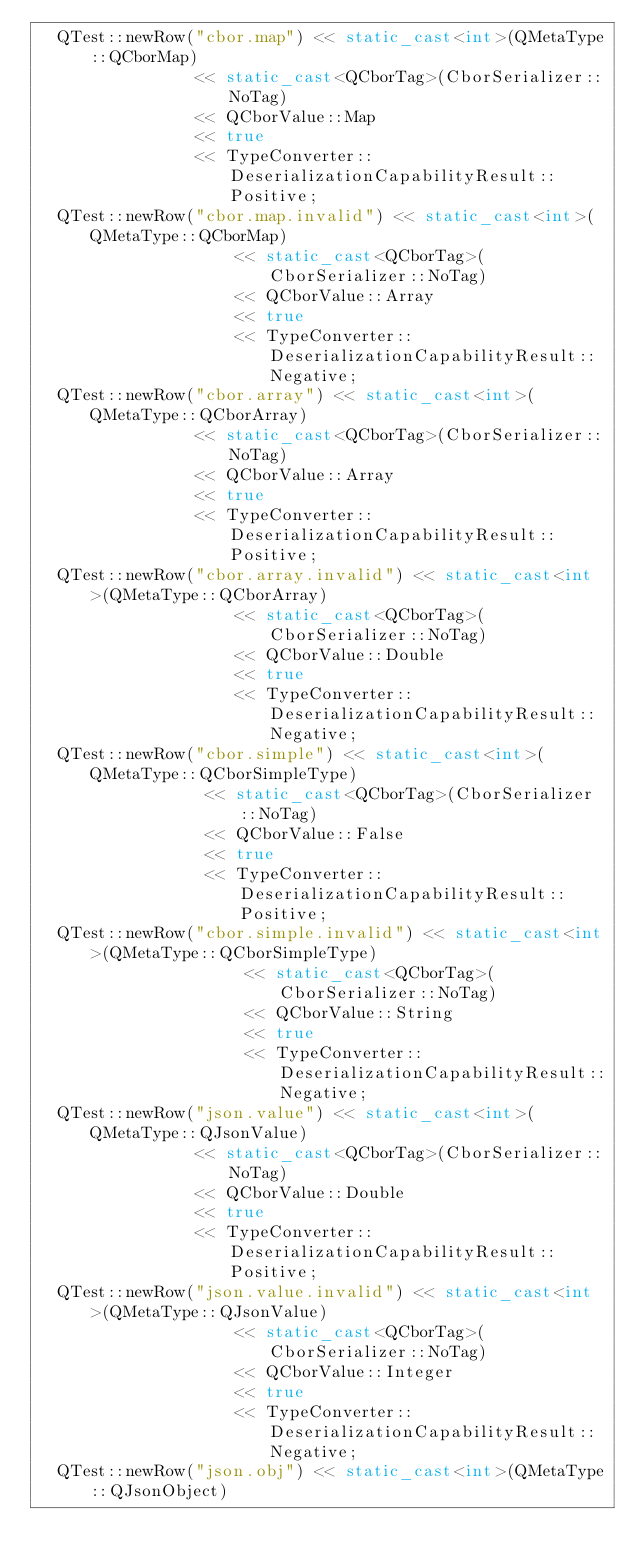<code> <loc_0><loc_0><loc_500><loc_500><_C++_>	QTest::newRow("cbor.map") << static_cast<int>(QMetaType::QCborMap)
							  << static_cast<QCborTag>(CborSerializer::NoTag)
							  << QCborValue::Map
							  << true
							  << TypeConverter::DeserializationCapabilityResult::Positive;
	QTest::newRow("cbor.map.invalid") << static_cast<int>(QMetaType::QCborMap)
									  << static_cast<QCborTag>(CborSerializer::NoTag)
									  << QCborValue::Array
									  << true
									  << TypeConverter::DeserializationCapabilityResult::Negative;
	QTest::newRow("cbor.array") << static_cast<int>(QMetaType::QCborArray)
								<< static_cast<QCborTag>(CborSerializer::NoTag)
								<< QCborValue::Array
								<< true
								<< TypeConverter::DeserializationCapabilityResult::Positive;
	QTest::newRow("cbor.array.invalid") << static_cast<int>(QMetaType::QCborArray)
										<< static_cast<QCborTag>(CborSerializer::NoTag)
										<< QCborValue::Double
										<< true
										<< TypeConverter::DeserializationCapabilityResult::Negative;
	QTest::newRow("cbor.simple") << static_cast<int>(QMetaType::QCborSimpleType)
								 << static_cast<QCborTag>(CborSerializer::NoTag)
								 << QCborValue::False
								 << true
								 << TypeConverter::DeserializationCapabilityResult::Positive;
	QTest::newRow("cbor.simple.invalid") << static_cast<int>(QMetaType::QCborSimpleType)
										 << static_cast<QCborTag>(CborSerializer::NoTag)
										 << QCborValue::String
										 << true
										 << TypeConverter::DeserializationCapabilityResult::Negative;
	QTest::newRow("json.value") << static_cast<int>(QMetaType::QJsonValue)
								<< static_cast<QCborTag>(CborSerializer::NoTag)
								<< QCborValue::Double
								<< true
								<< TypeConverter::DeserializationCapabilityResult::Positive;
	QTest::newRow("json.value.invalid") << static_cast<int>(QMetaType::QJsonValue)
										<< static_cast<QCborTag>(CborSerializer::NoTag)
										<< QCborValue::Integer
										<< true
										<< TypeConverter::DeserializationCapabilityResult::Negative;
	QTest::newRow("json.obj") << static_cast<int>(QMetaType::QJsonObject)</code> 